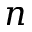Convert formula to latex. <formula><loc_0><loc_0><loc_500><loc_500>n</formula> 